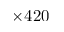<formula> <loc_0><loc_0><loc_500><loc_500>\times 4 2 0</formula> 